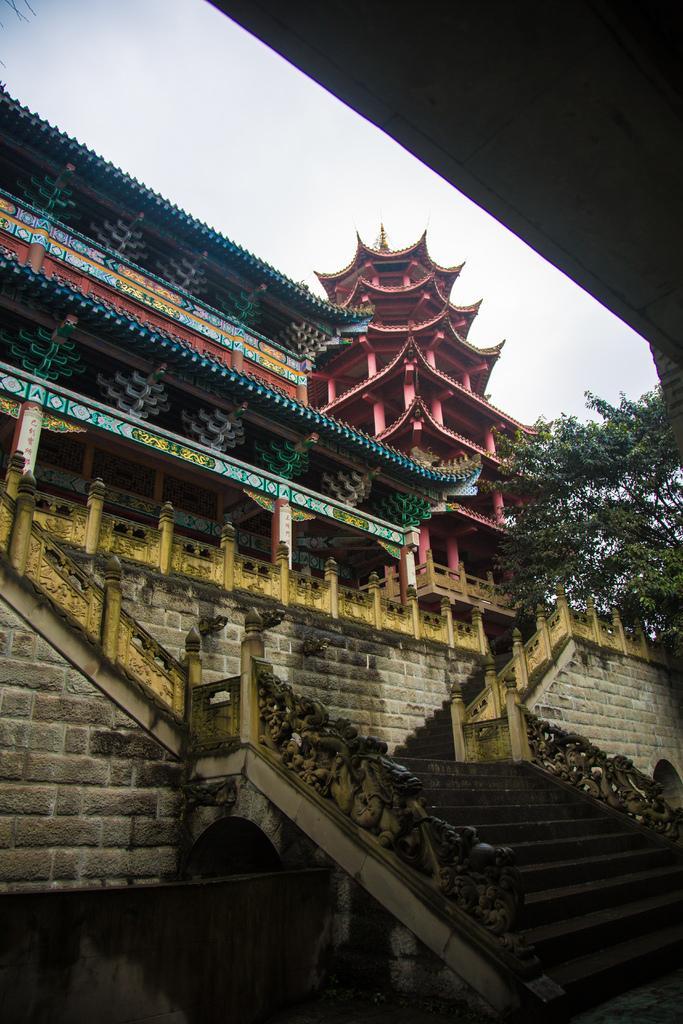Can you describe this image briefly? At the bottom of the picture, we see a wall. On the right side, we see the staircase and the stair railing. In the middle, we see a building which is made up of cobblestones. We see the railing and we see the roof of the building in blue color. Beside that, we see a building in red color. On the right side, we see the trees. In the left top, we see the sky. In the right top, it is black in color and it might be the roof of the building. 